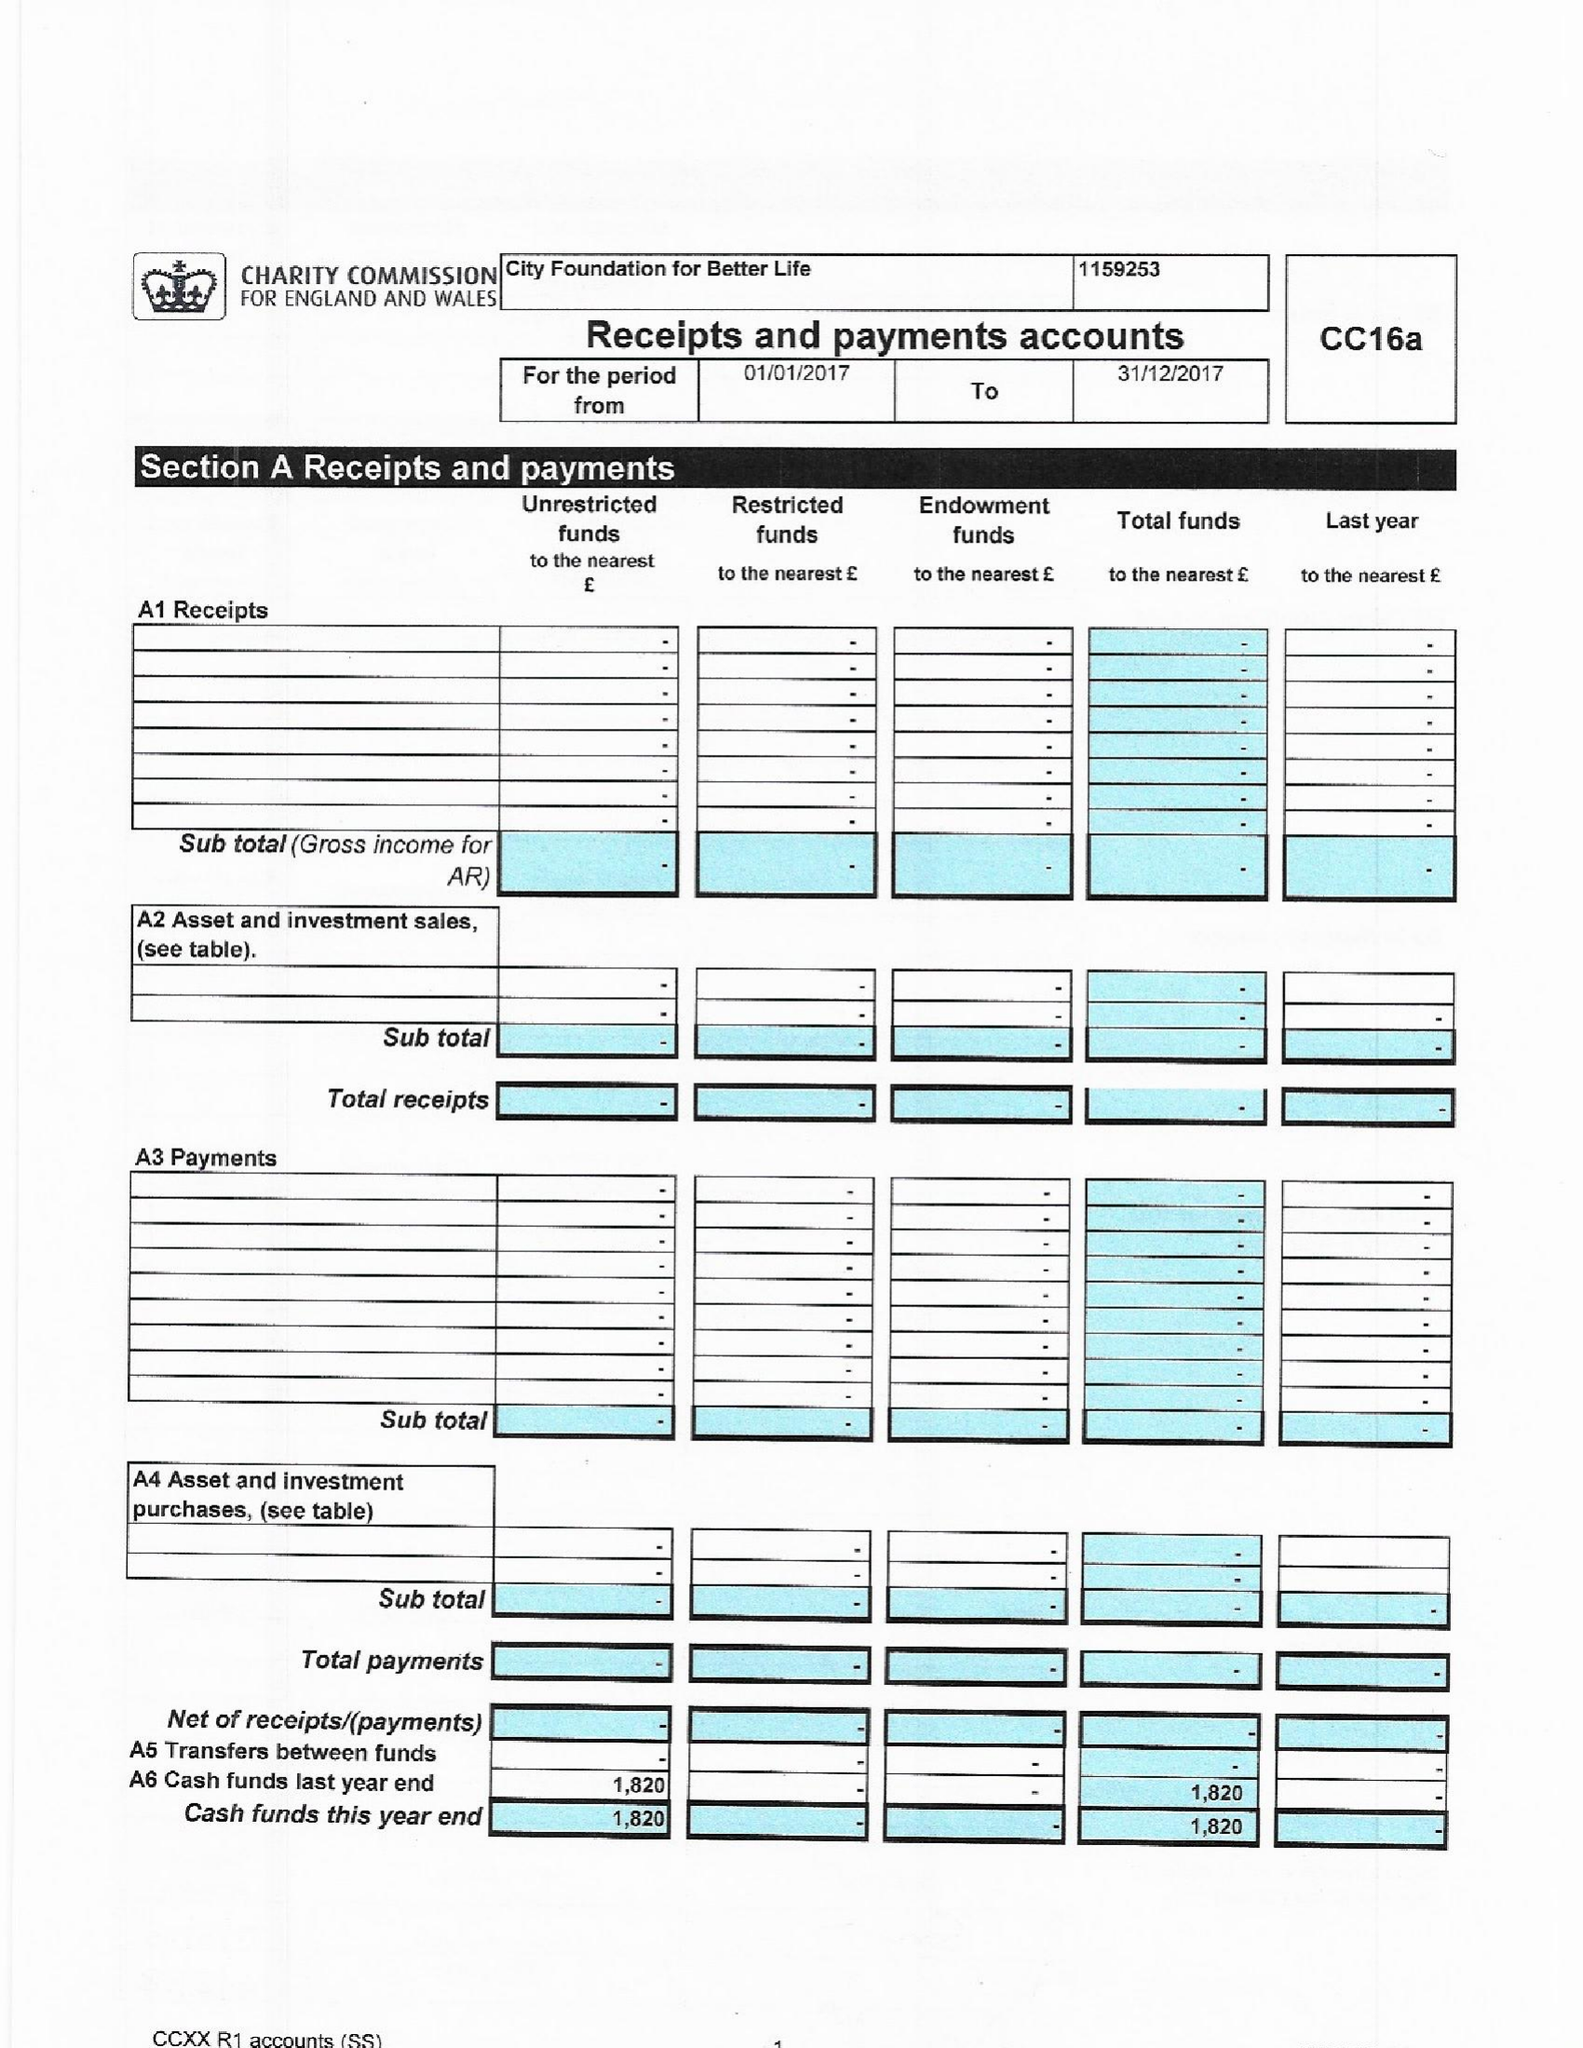What is the value for the charity_name?
Answer the question using a single word or phrase. City Foundation For Better Life 